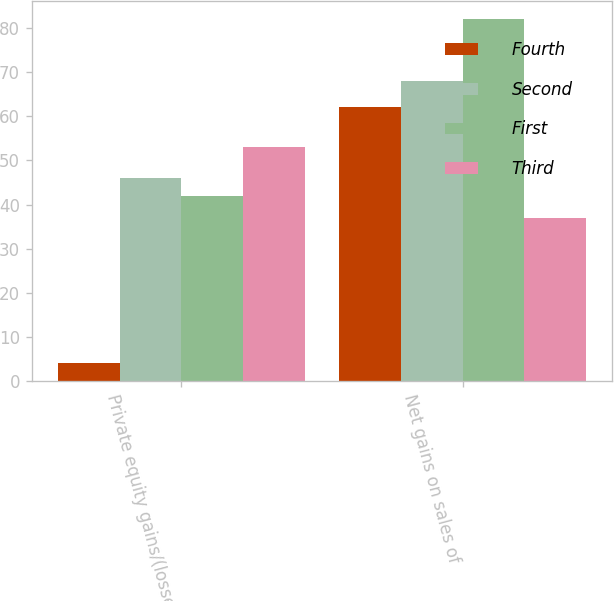Convert chart to OTSL. <chart><loc_0><loc_0><loc_500><loc_500><stacked_bar_chart><ecel><fcel>Private equity gains/(losses)<fcel>Net gains on sales of<nl><fcel>Fourth<fcel>4<fcel>62<nl><fcel>Second<fcel>46<fcel>68<nl><fcel>First<fcel>42<fcel>82<nl><fcel>Third<fcel>53<fcel>37<nl></chart> 